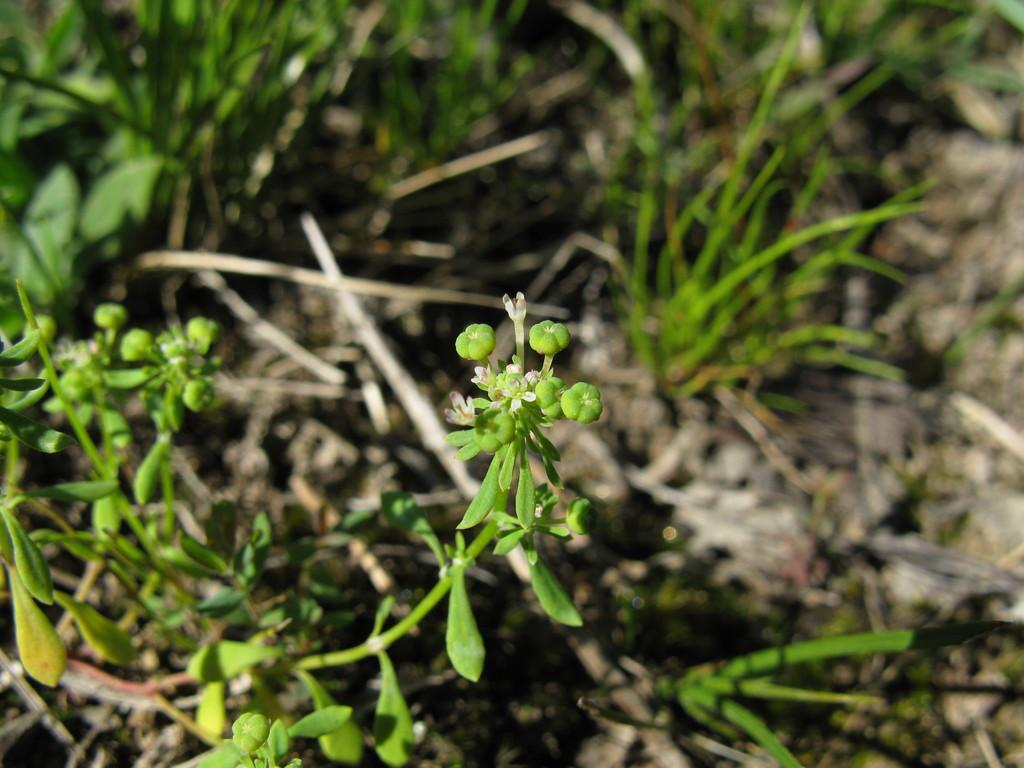What celestial bodies can be seen in the image? There are planets visible in the image. What type of vegetation is present in the image? There is grass in the image. What country does the mother belong to in the image? There is no mother or country present in the image; it features planets and grass. 